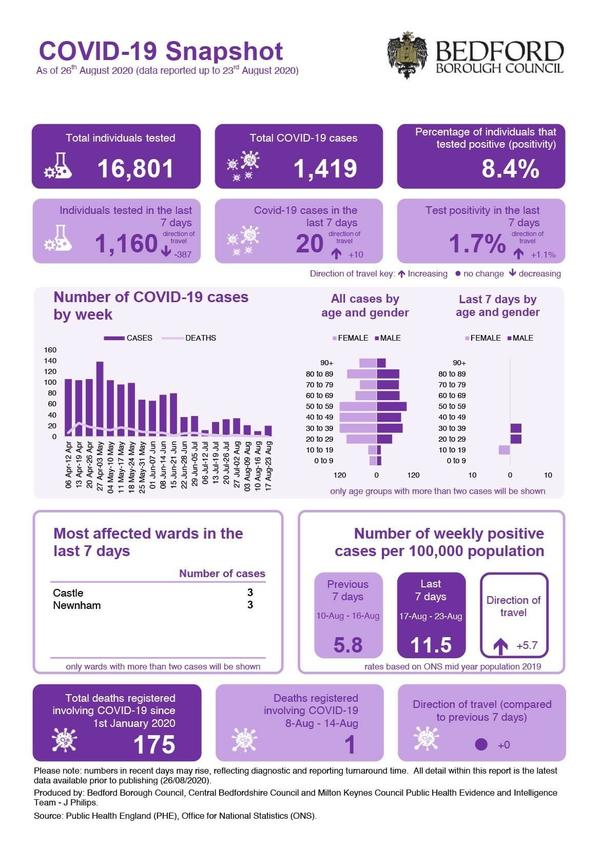Indicate a few pertinent items in this graphic. As of January 1, 2020, a total of 175 COVID-19 deaths have been registered in Bedford Borough. As of August 26th, 2020, the number of COVID-19 cases in Newnham is 3. As of August 26th, 2020, the total number of COVID-19 cases reported in Bedford Borough is 1,419. As of August 26th, 2020, there have been a total of 16,801 individuals tested for COVID-19 in Bedford Borough. As of August 26th, 2020, in Bedford Borough, 8.4% of individuals tested positive for the coronavirus. 